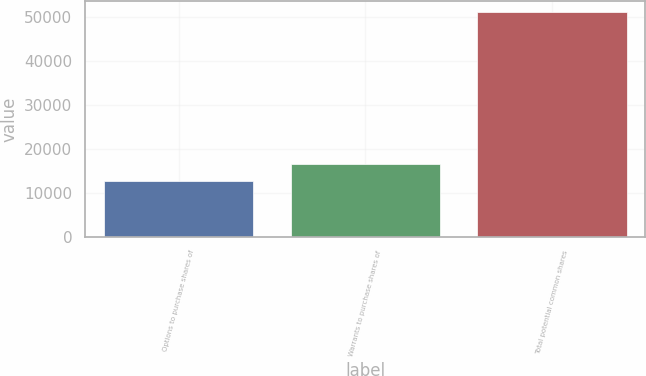Convert chart. <chart><loc_0><loc_0><loc_500><loc_500><bar_chart><fcel>Options to purchase shares of<fcel>Warrants to purchase shares of<fcel>Total potential common shares<nl><fcel>12642<fcel>16477.7<fcel>50999<nl></chart> 